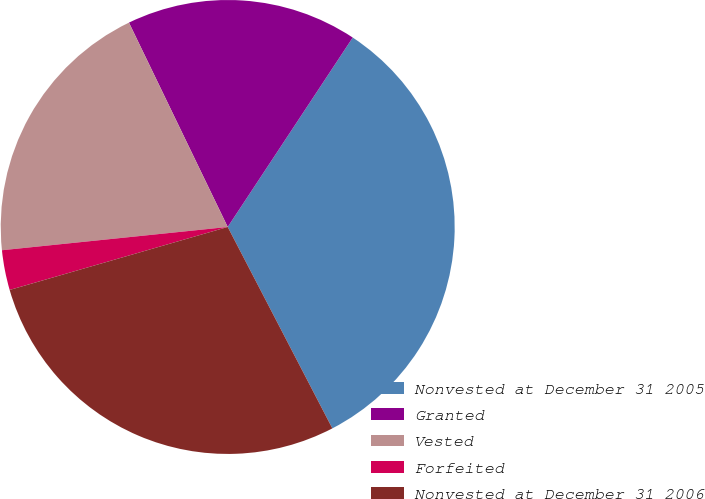Convert chart to OTSL. <chart><loc_0><loc_0><loc_500><loc_500><pie_chart><fcel>Nonvested at December 31 2005<fcel>Granted<fcel>Vested<fcel>Forfeited<fcel>Nonvested at December 31 2006<nl><fcel>33.09%<fcel>16.45%<fcel>19.47%<fcel>2.84%<fcel>28.15%<nl></chart> 